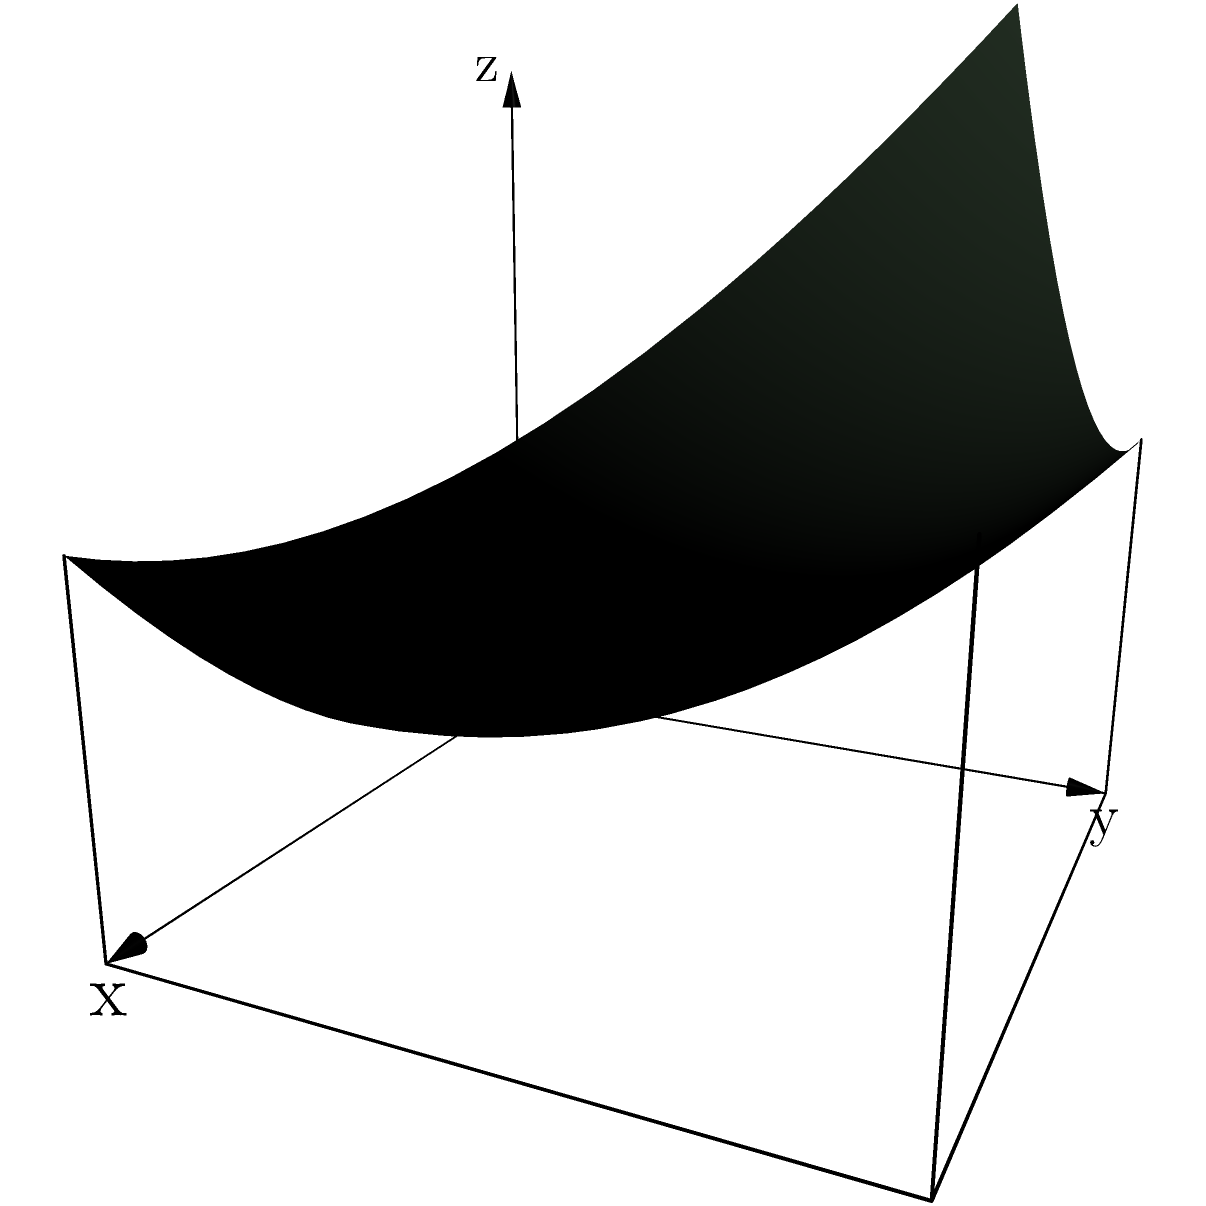A sustainable fuel tank for a racing team is modeled by the region bounded by the surface $z = 0.5x^2 + 0.3y^2$, the xy-plane, and the planes $x = 3$ and $y = 4$. Calculate the volume of sustainable fuel (in cubic units) that this tank can hold for a race season. To find the volume of the fuel tank, we need to set up and evaluate a triple integral:

1) The volume is given by: $V = \iiint_R dV = \int_0^4 \int_0^3 \int_0^{0.5x^2 + 0.3y^2} dz dx dy$

2) Evaluate the innermost integral:
   $\int_0^4 \int_0^3 [z]_0^{0.5x^2 + 0.3y^2} dx dy = \int_0^4 \int_0^3 (0.5x^2 + 0.3y^2) dx dy$

3) Evaluate the integral with respect to x:
   $\int_0^4 [\frac{1}{3}(0.5x^3 + 0.3y^2x)]_0^3 dy = \int_0^4 (1.5 + 0.9y^2) dy$

4) Finally, evaluate the integral with respect to y:
   $[1.5y + 0.3y^3]_0^4 = (6 + 19.2) - 0 = 25.2$

Therefore, the volume of the fuel tank is 25.2 cubic units.
Answer: 25.2 cubic units 